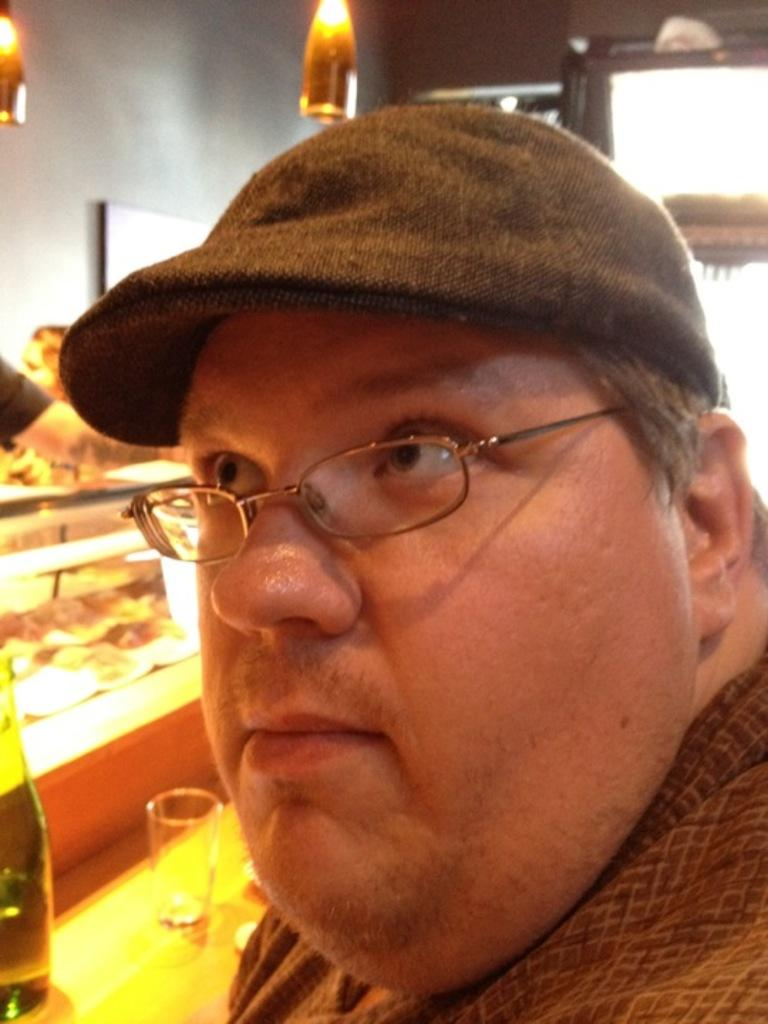What is the main subject of the image? There is a person's face in the image. What can be seen on the person's face? The person is wearing spectacles. What part of the person's body is visible in the image? There is a person's hand visible in the image. What type of furniture is present in the image? There is a glass table in the image. What can be seen illuminating the scene? There are lights in the image. What type of architectural feature is present in the image? There is a wall in the image. What type of slope can be seen in the image? There is no slope present in the image. How can the person in the image be helped? The image does not provide any information about the person needing help, so it cannot be determined from the image. 